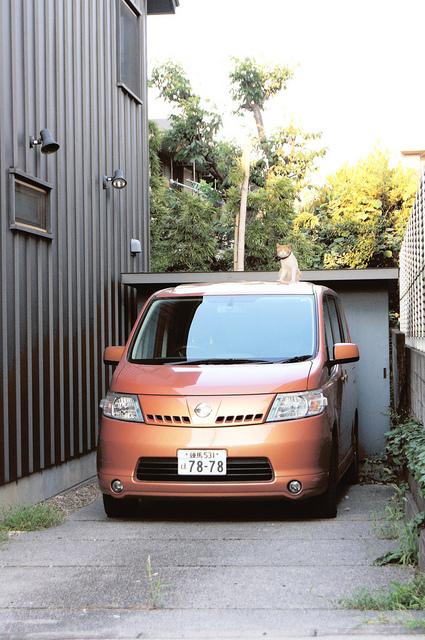Is this vehicle parked in a residential driveway?
Write a very short answer. Yes. Is the color of the car very common for vehicles?
Quick response, please. No. What color is the car?
Quick response, please. Orange. 